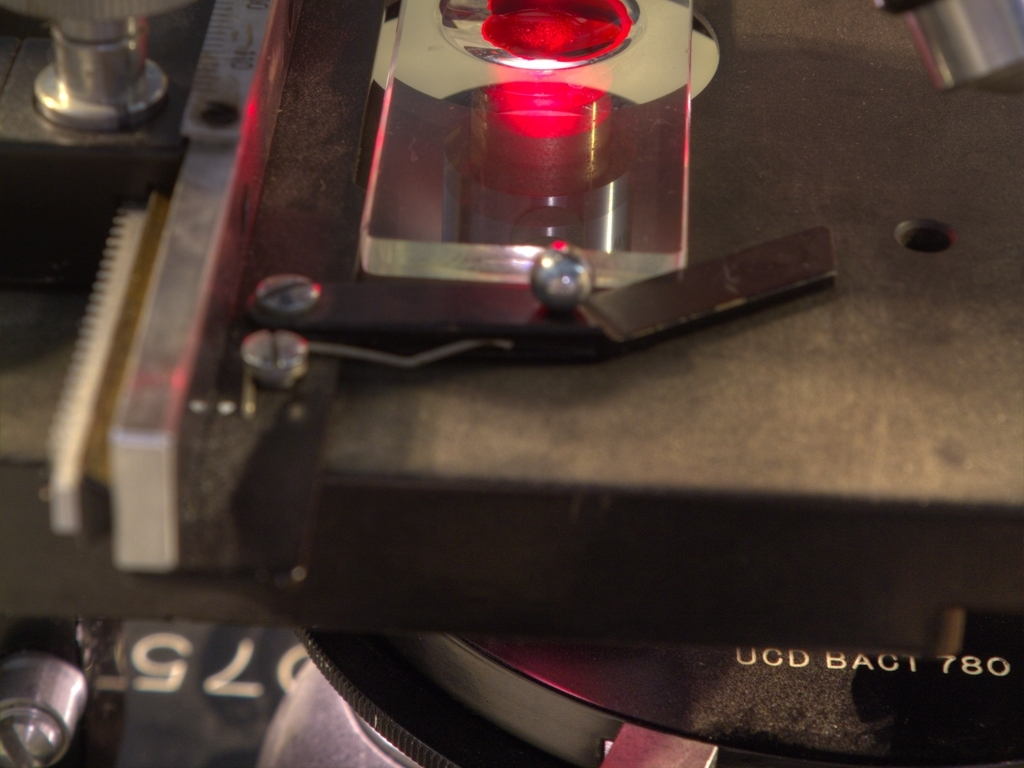What is the function of this equipment? This equipment appears to be part of a scientific apparatus, possibly a microscope or laser-based measurement device, used for detailed analytical tasks requiring precision. Could you explain what the red light might indicate? The red light could be part of a laser system which is used for measurement or analysis, often as a precise reference point or in tasks like spectrometry. 